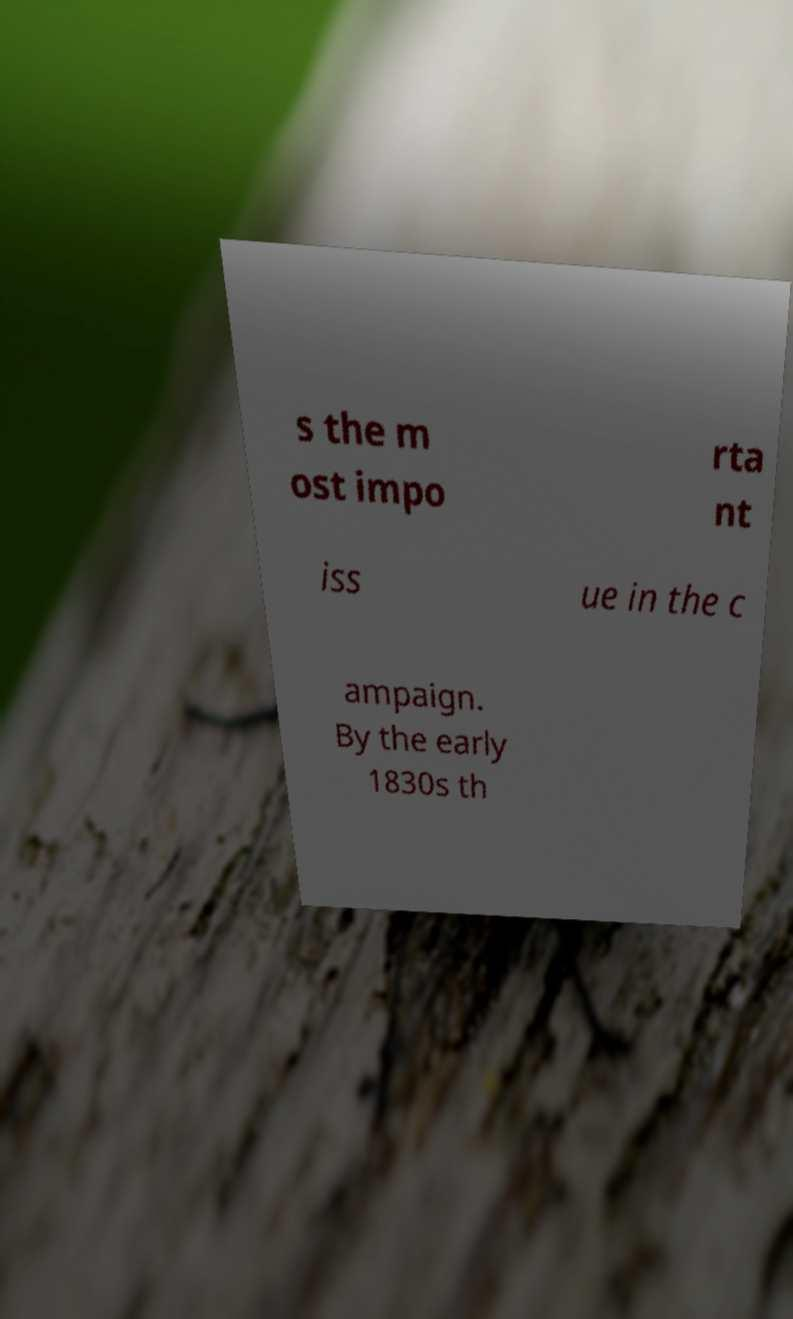Could you assist in decoding the text presented in this image and type it out clearly? s the m ost impo rta nt iss ue in the c ampaign. By the early 1830s th 